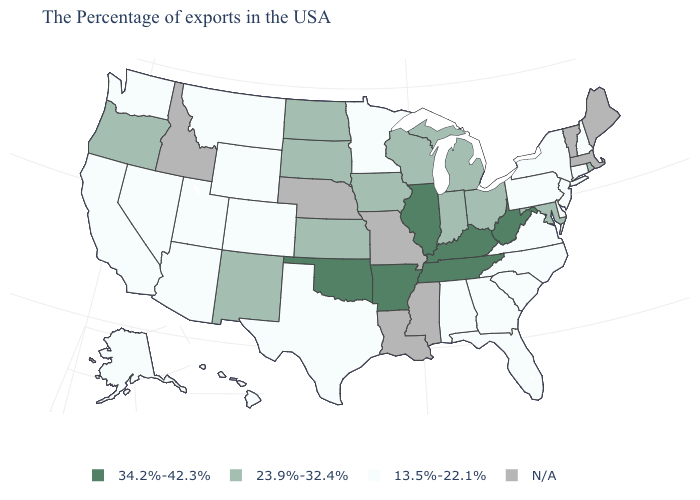Which states have the lowest value in the USA?
Keep it brief. New Hampshire, Connecticut, New York, New Jersey, Delaware, Pennsylvania, Virginia, North Carolina, South Carolina, Florida, Georgia, Alabama, Minnesota, Texas, Wyoming, Colorado, Utah, Montana, Arizona, Nevada, California, Washington, Alaska, Hawaii. What is the value of New Jersey?
Short answer required. 13.5%-22.1%. What is the lowest value in the Northeast?
Answer briefly. 13.5%-22.1%. How many symbols are there in the legend?
Keep it brief. 4. Among the states that border West Virginia , which have the highest value?
Concise answer only. Kentucky. What is the value of Louisiana?
Be succinct. N/A. Among the states that border Nevada , which have the highest value?
Write a very short answer. Oregon. Which states have the highest value in the USA?
Quick response, please. West Virginia, Kentucky, Tennessee, Illinois, Arkansas, Oklahoma. What is the lowest value in states that border Idaho?
Give a very brief answer. 13.5%-22.1%. Among the states that border Tennessee , which have the lowest value?
Concise answer only. Virginia, North Carolina, Georgia, Alabama. Which states hav the highest value in the South?
Answer briefly. West Virginia, Kentucky, Tennessee, Arkansas, Oklahoma. Does the first symbol in the legend represent the smallest category?
Be succinct. No. What is the lowest value in the West?
Short answer required. 13.5%-22.1%. Among the states that border Mississippi , which have the highest value?
Give a very brief answer. Tennessee, Arkansas. 